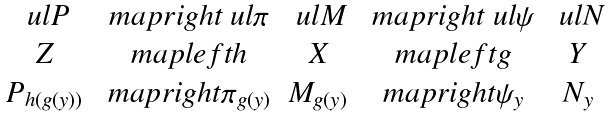Convert formula to latex. <formula><loc_0><loc_0><loc_500><loc_500>\begin{matrix} \ u l { P } & \ m a p r i g h t { \ u l { \pi } } & \ u l { M } & \ m a p r i g h t { \ u l { \psi } } & \ u l { N } \\ Z & \ m a p l e f t { h } & X & \ m a p l e f t { g } & Y \\ P _ { h ( g ( y ) ) } & \ m a p r i g h t { \pi _ { g ( y ) } } & M _ { g ( y ) } & \ m a p r i g h t { \psi _ { y } } & N _ { y } \end{matrix}</formula> 